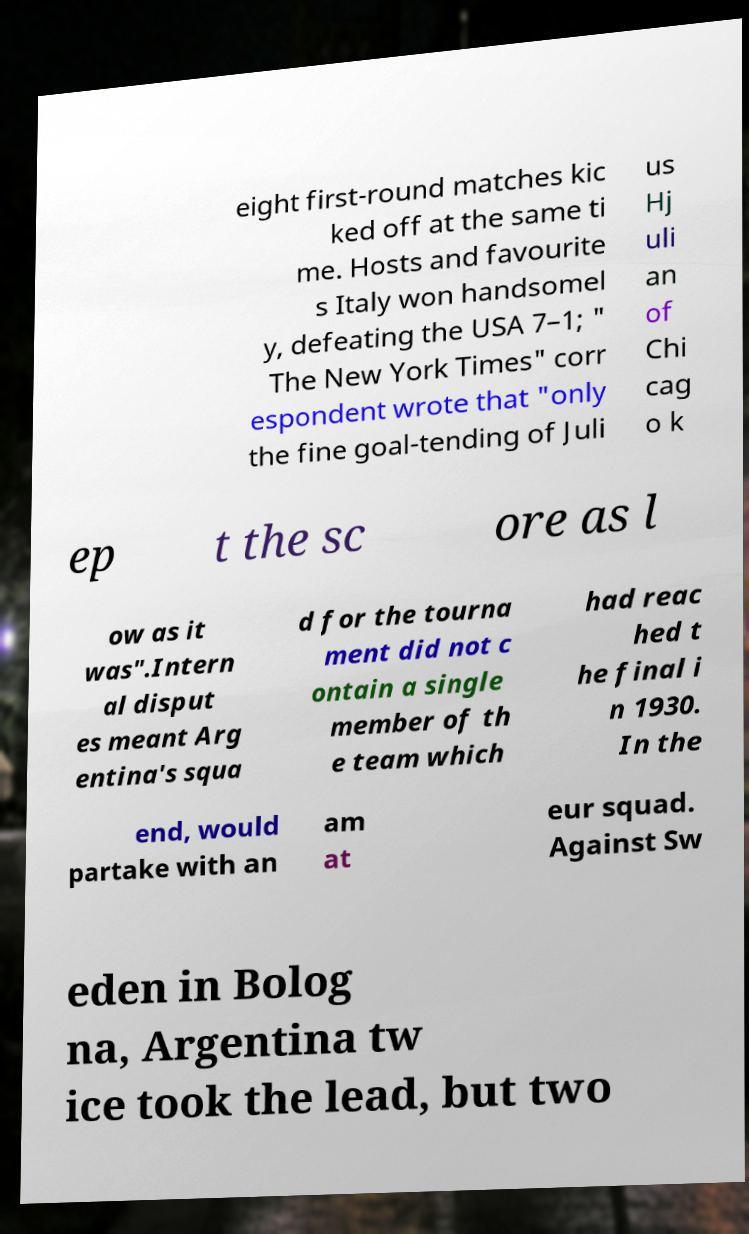Could you assist in decoding the text presented in this image and type it out clearly? eight first-round matches kic ked off at the same ti me. Hosts and favourite s Italy won handsomel y, defeating the USA 7–1; " The New York Times" corr espondent wrote that "only the fine goal-tending of Juli us Hj uli an of Chi cag o k ep t the sc ore as l ow as it was".Intern al disput es meant Arg entina's squa d for the tourna ment did not c ontain a single member of th e team which had reac hed t he final i n 1930. In the end, would partake with an am at eur squad. Against Sw eden in Bolog na, Argentina tw ice took the lead, but two 